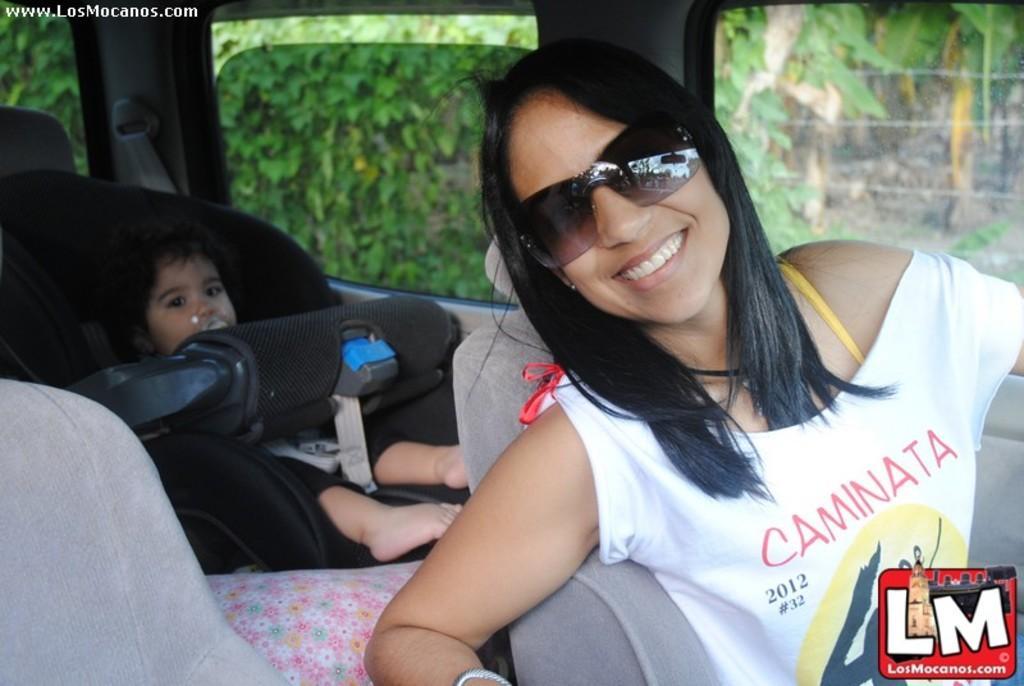Can you describe this image briefly? In this picture I can see the inside view of a vehicle, there is a woman smiling and sitting on the seat, there is a baby on another seat, and in the background there are plants and there are watermarks on the image. 